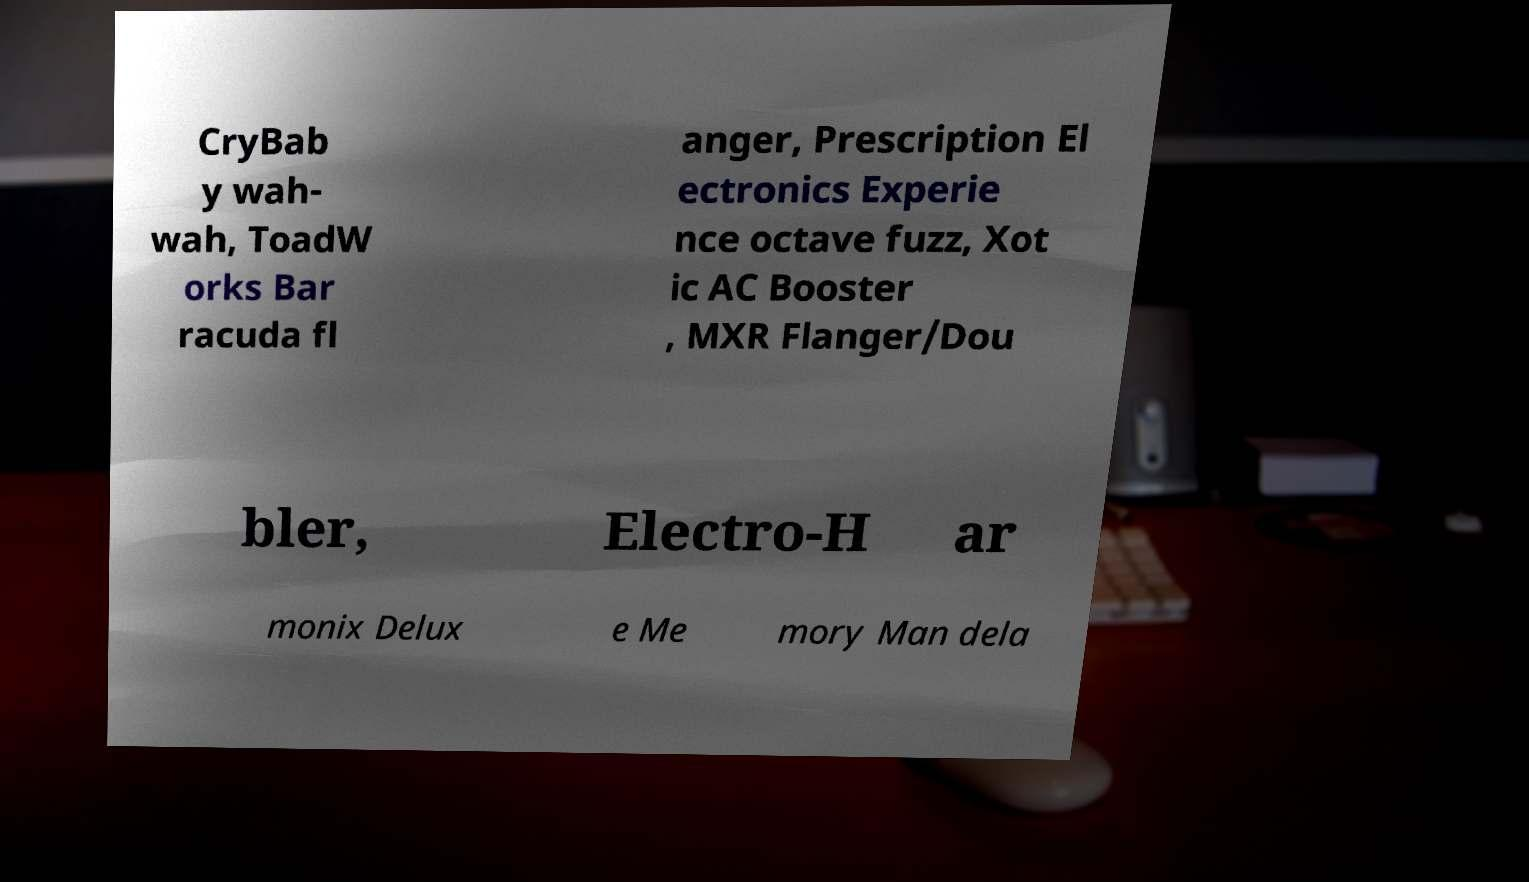Please read and relay the text visible in this image. What does it say? CryBab y wah- wah, ToadW orks Bar racuda fl anger, Prescription El ectronics Experie nce octave fuzz, Xot ic AC Booster , MXR Flanger/Dou bler, Electro-H ar monix Delux e Me mory Man dela 